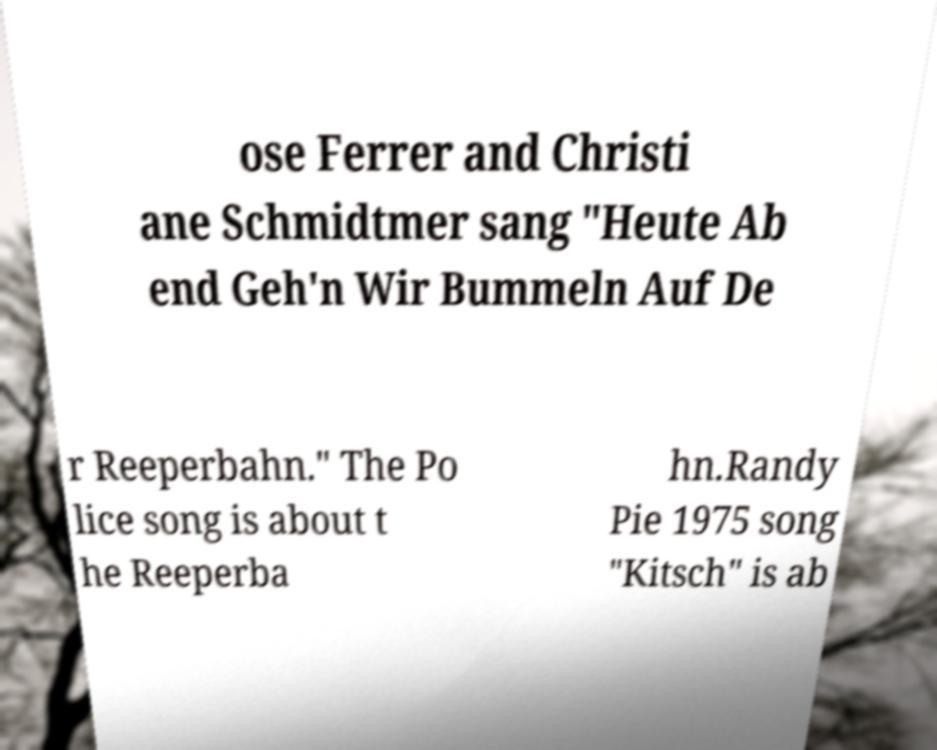I need the written content from this picture converted into text. Can you do that? ose Ferrer and Christi ane Schmidtmer sang "Heute Ab end Geh'n Wir Bummeln Auf De r Reeperbahn." The Po lice song is about t he Reeperba hn.Randy Pie 1975 song "Kitsch" is ab 